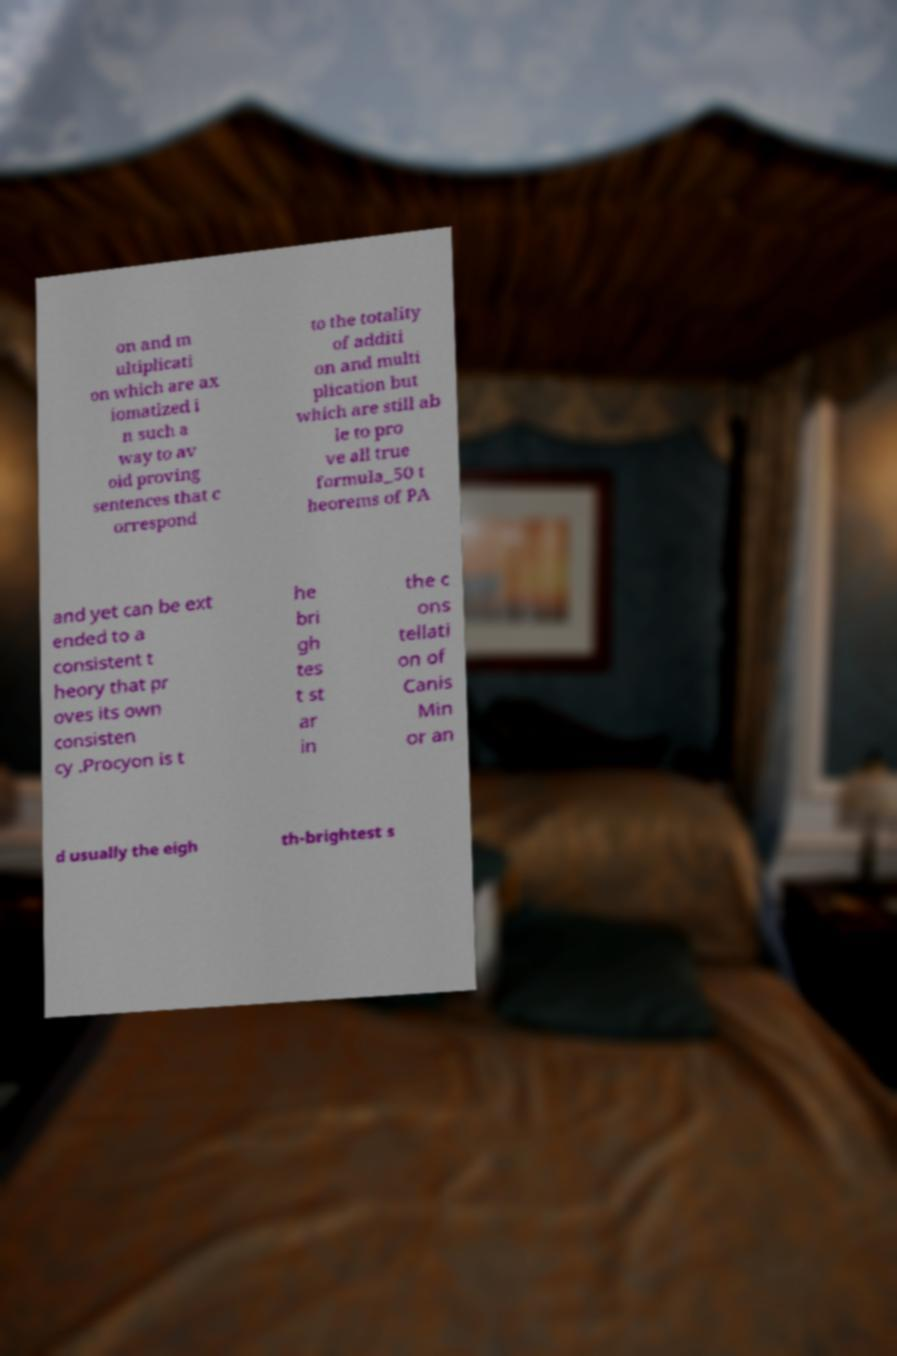Could you extract and type out the text from this image? on and m ultiplicati on which are ax iomatized i n such a way to av oid proving sentences that c orrespond to the totality of additi on and multi plication but which are still ab le to pro ve all true formula_50 t heorems of PA and yet can be ext ended to a consistent t heory that pr oves its own consisten cy .Procyon is t he bri gh tes t st ar in the c ons tellati on of Canis Min or an d usually the eigh th-brightest s 